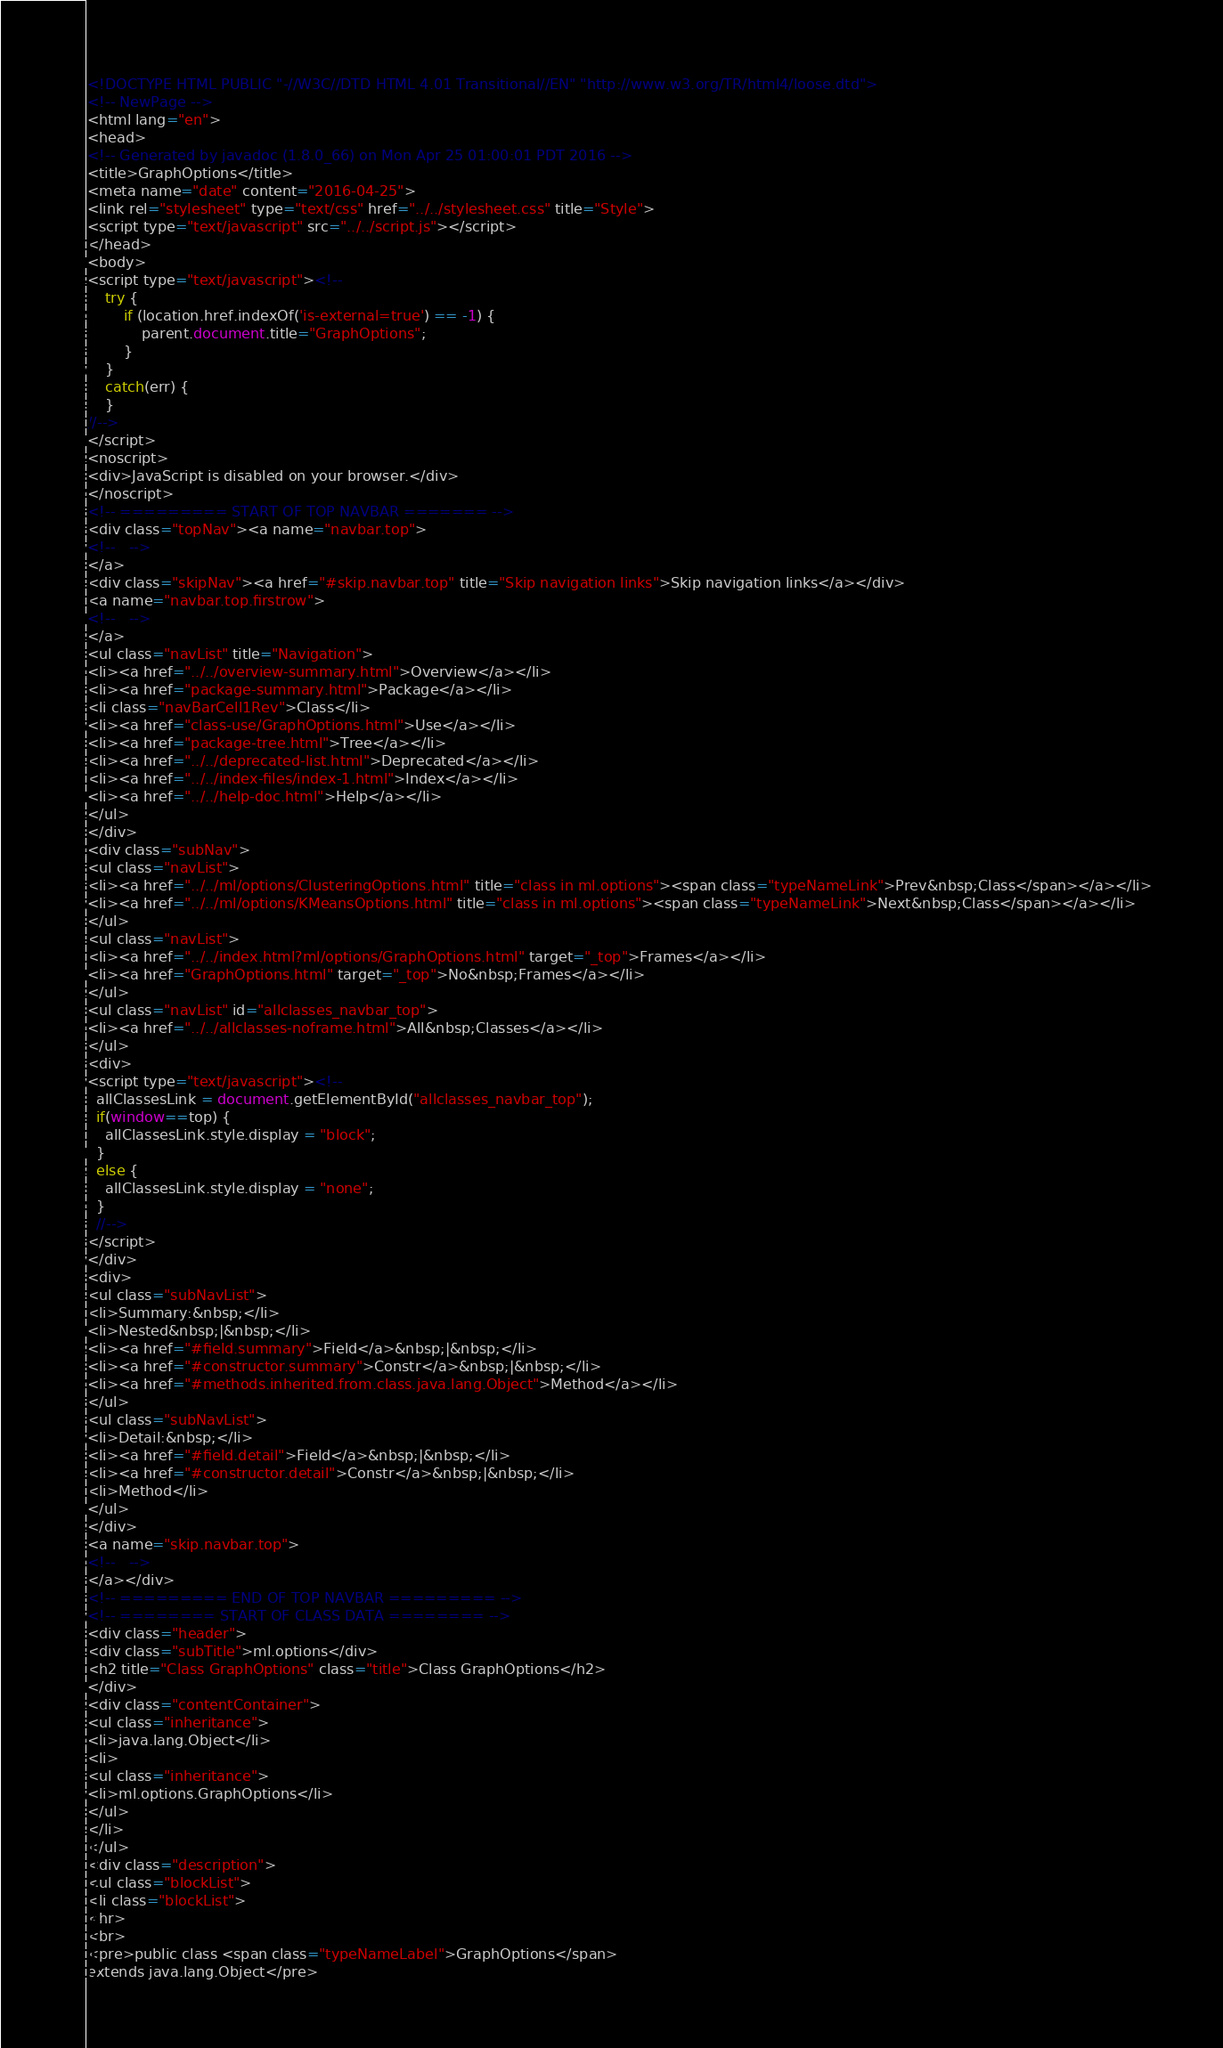Convert code to text. <code><loc_0><loc_0><loc_500><loc_500><_HTML_><!DOCTYPE HTML PUBLIC "-//W3C//DTD HTML 4.01 Transitional//EN" "http://www.w3.org/TR/html4/loose.dtd">
<!-- NewPage -->
<html lang="en">
<head>
<!-- Generated by javadoc (1.8.0_66) on Mon Apr 25 01:00:01 PDT 2016 -->
<title>GraphOptions</title>
<meta name="date" content="2016-04-25">
<link rel="stylesheet" type="text/css" href="../../stylesheet.css" title="Style">
<script type="text/javascript" src="../../script.js"></script>
</head>
<body>
<script type="text/javascript"><!--
    try {
        if (location.href.indexOf('is-external=true') == -1) {
            parent.document.title="GraphOptions";
        }
    }
    catch(err) {
    }
//-->
</script>
<noscript>
<div>JavaScript is disabled on your browser.</div>
</noscript>
<!-- ========= START OF TOP NAVBAR ======= -->
<div class="topNav"><a name="navbar.top">
<!--   -->
</a>
<div class="skipNav"><a href="#skip.navbar.top" title="Skip navigation links">Skip navigation links</a></div>
<a name="navbar.top.firstrow">
<!--   -->
</a>
<ul class="navList" title="Navigation">
<li><a href="../../overview-summary.html">Overview</a></li>
<li><a href="package-summary.html">Package</a></li>
<li class="navBarCell1Rev">Class</li>
<li><a href="class-use/GraphOptions.html">Use</a></li>
<li><a href="package-tree.html">Tree</a></li>
<li><a href="../../deprecated-list.html">Deprecated</a></li>
<li><a href="../../index-files/index-1.html">Index</a></li>
<li><a href="../../help-doc.html">Help</a></li>
</ul>
</div>
<div class="subNav">
<ul class="navList">
<li><a href="../../ml/options/ClusteringOptions.html" title="class in ml.options"><span class="typeNameLink">Prev&nbsp;Class</span></a></li>
<li><a href="../../ml/options/KMeansOptions.html" title="class in ml.options"><span class="typeNameLink">Next&nbsp;Class</span></a></li>
</ul>
<ul class="navList">
<li><a href="../../index.html?ml/options/GraphOptions.html" target="_top">Frames</a></li>
<li><a href="GraphOptions.html" target="_top">No&nbsp;Frames</a></li>
</ul>
<ul class="navList" id="allclasses_navbar_top">
<li><a href="../../allclasses-noframe.html">All&nbsp;Classes</a></li>
</ul>
<div>
<script type="text/javascript"><!--
  allClassesLink = document.getElementById("allclasses_navbar_top");
  if(window==top) {
    allClassesLink.style.display = "block";
  }
  else {
    allClassesLink.style.display = "none";
  }
  //-->
</script>
</div>
<div>
<ul class="subNavList">
<li>Summary:&nbsp;</li>
<li>Nested&nbsp;|&nbsp;</li>
<li><a href="#field.summary">Field</a>&nbsp;|&nbsp;</li>
<li><a href="#constructor.summary">Constr</a>&nbsp;|&nbsp;</li>
<li><a href="#methods.inherited.from.class.java.lang.Object">Method</a></li>
</ul>
<ul class="subNavList">
<li>Detail:&nbsp;</li>
<li><a href="#field.detail">Field</a>&nbsp;|&nbsp;</li>
<li><a href="#constructor.detail">Constr</a>&nbsp;|&nbsp;</li>
<li>Method</li>
</ul>
</div>
<a name="skip.navbar.top">
<!--   -->
</a></div>
<!-- ========= END OF TOP NAVBAR ========= -->
<!-- ======== START OF CLASS DATA ======== -->
<div class="header">
<div class="subTitle">ml.options</div>
<h2 title="Class GraphOptions" class="title">Class GraphOptions</h2>
</div>
<div class="contentContainer">
<ul class="inheritance">
<li>java.lang.Object</li>
<li>
<ul class="inheritance">
<li>ml.options.GraphOptions</li>
</ul>
</li>
</ul>
<div class="description">
<ul class="blockList">
<li class="blockList">
<hr>
<br>
<pre>public class <span class="typeNameLabel">GraphOptions</span>
extends java.lang.Object</pre></code> 